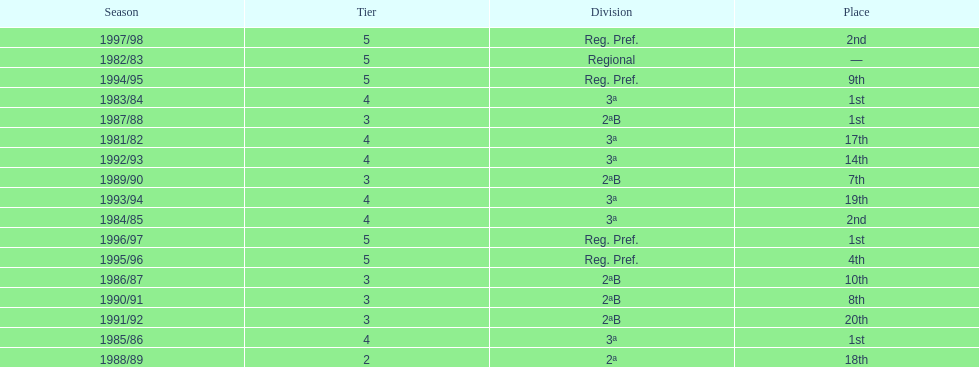How many years were they in tier 3 5. 